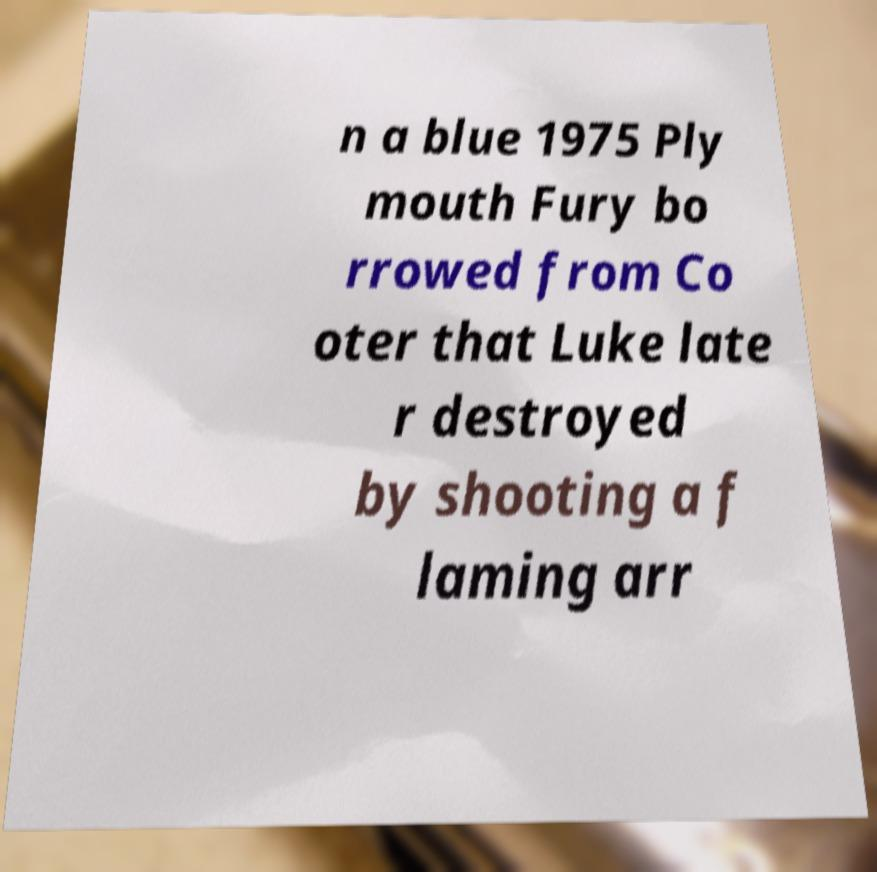I need the written content from this picture converted into text. Can you do that? n a blue 1975 Ply mouth Fury bo rrowed from Co oter that Luke late r destroyed by shooting a f laming arr 